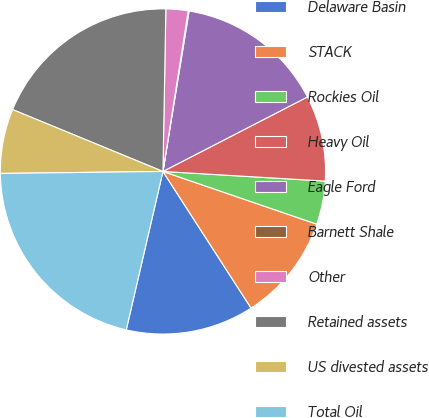<chart> <loc_0><loc_0><loc_500><loc_500><pie_chart><fcel>Delaware Basin<fcel>STACK<fcel>Rockies Oil<fcel>Heavy Oil<fcel>Eagle Ford<fcel>Barnett Shale<fcel>Other<fcel>Retained assets<fcel>US divested assets<fcel>Total Oil<nl><fcel>12.74%<fcel>10.63%<fcel>4.31%<fcel>8.52%<fcel>14.85%<fcel>0.09%<fcel>2.2%<fcel>19.07%<fcel>6.41%<fcel>21.18%<nl></chart> 